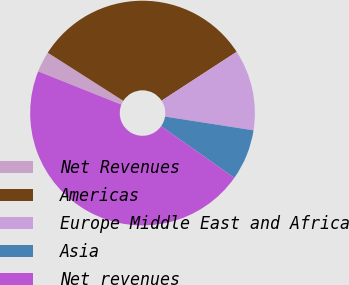Convert chart to OTSL. <chart><loc_0><loc_0><loc_500><loc_500><pie_chart><fcel>Net Revenues<fcel>Americas<fcel>Europe Middle East and Africa<fcel>Asia<fcel>Net revenues<nl><fcel>2.98%<fcel>31.79%<fcel>11.64%<fcel>7.31%<fcel>46.28%<nl></chart> 